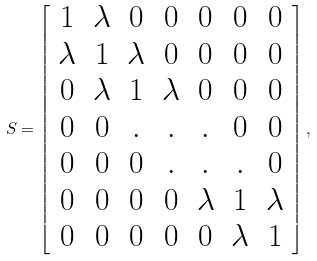<formula> <loc_0><loc_0><loc_500><loc_500>S = \left [ \begin{array} { c c c c c c c } 1 & \lambda & 0 & 0 & 0 & 0 & 0 \\ \lambda & 1 & \lambda & 0 & 0 & 0 & 0 \\ 0 & \lambda & 1 & \lambda & 0 & 0 & 0 \\ 0 & 0 & . & . & . & 0 & 0 \\ 0 & 0 & 0 & . & . & . & 0 \\ 0 & 0 & 0 & 0 & \lambda & 1 & \lambda \\ 0 & 0 & 0 & 0 & 0 & \lambda & 1 \end{array} \right ] ,</formula> 